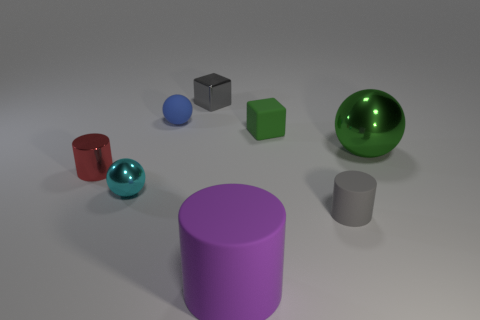Can you describe the colors of the objects in the image? Certainly! In the image, there are objects with various colors: a red cylinder, a blue sphere, a green cube, a shiny green sphere, and a purple cylinder, along with gray objects that appear metallic and plastic. 